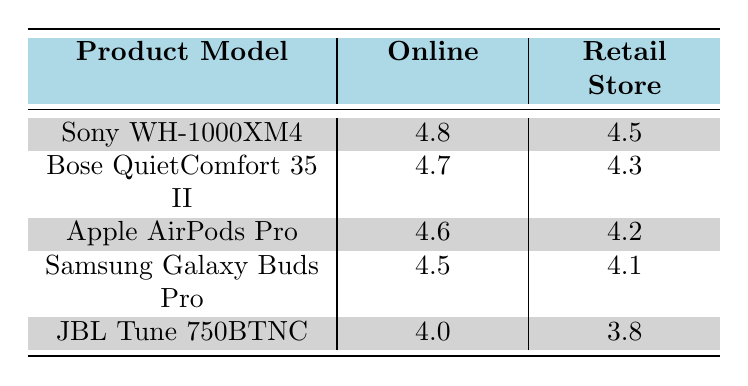What is the satisfaction rating for the Bose QuietComfort 35 II sold online? According to the table, the satisfaction rating for the Bose QuietComfort 35 II in the online distribution channel is listed as 4.7.
Answer: 4.7 What is the difference in satisfaction ratings between the Apple AirPods Pro sold online and in retail stores? The satisfaction rating for Apple AirPods Pro online is 4.6, while in retail stores it is 4.2. To find the difference, subtract the retail rating from the online rating: 4.6 - 4.2 = 0.4.
Answer: 0.4 Is the satisfaction rating for the Sony WH-1000XM4 higher in retail stores than for the Samsung Galaxy Buds Pro sold online? The satisfaction rating for the Sony WH-1000XM4 in retail stores is 4.5, whereas the Samsung Galaxy Buds Pro sold online has a satisfaction rating of 4.5. Since 4.5 is not higher than 4.5, the answer is no.
Answer: No What is the average satisfaction rating for all products sold online? The satisfaction ratings for online sales are: 4.8, 4.7, 4.6, 4.5, and 4.0. To calculate the average, sum these ratings: 4.8 + 4.7 + 4.6 + 4.5 + 4.0 = 22.6, then divide by 5 (the number of products): 22.6 / 5 = 4.52.
Answer: 4.52 Which product model has the lowest satisfaction rating in retail stores? From the table, the satisfaction ratings for retail stores are: 4.5 (Sony WH-1000XM4), 4.3 (Bose QuietComfort 35 II), 4.2 (Apple AirPods Pro), 4.1 (Samsung Galaxy Buds Pro), and 3.8 (JBL Tune 750BTNC). The lowest rating is for JBL Tune 750BTNC at 3.8.
Answer: JBL Tune 750BTNC 